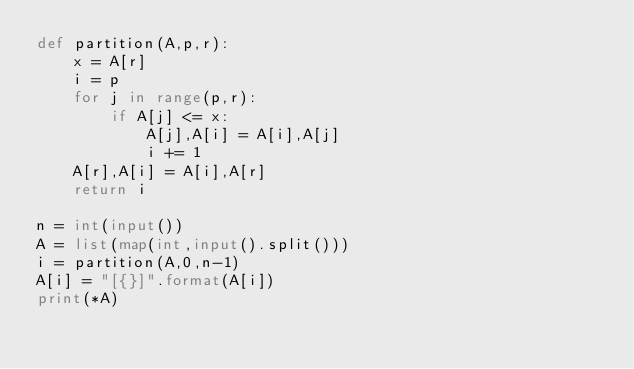Convert code to text. <code><loc_0><loc_0><loc_500><loc_500><_Python_>def partition(A,p,r):
    x = A[r]
    i = p
    for j in range(p,r):
        if A[j] <= x:
            A[j],A[i] = A[i],A[j]
            i += 1
    A[r],A[i] = A[i],A[r]
    return i

n = int(input())
A = list(map(int,input().split()))
i = partition(A,0,n-1)
A[i] = "[{}]".format(A[i])
print(*A)</code> 